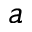Convert formula to latex. <formula><loc_0><loc_0><loc_500><loc_500>_ { a }</formula> 